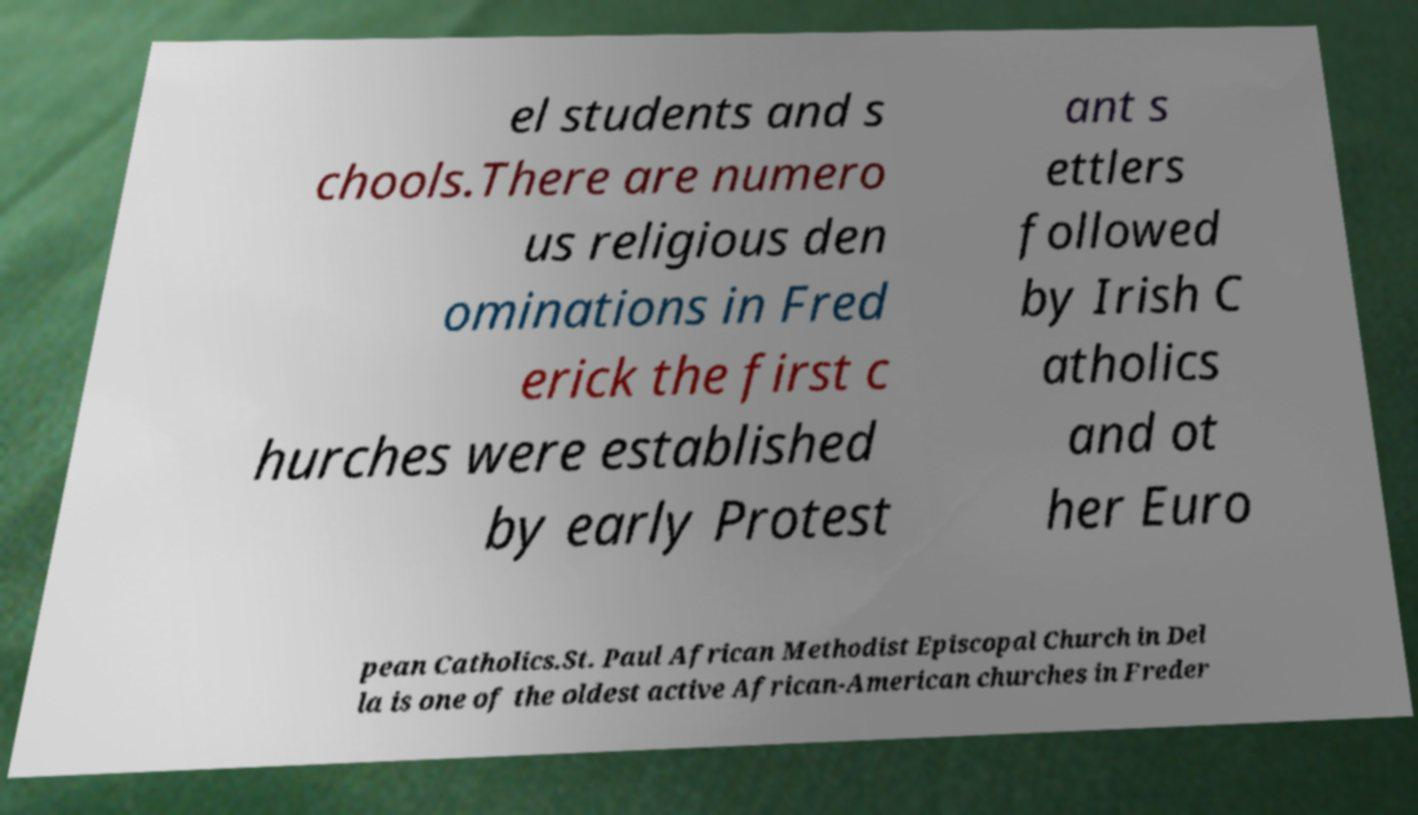I need the written content from this picture converted into text. Can you do that? el students and s chools.There are numero us religious den ominations in Fred erick the first c hurches were established by early Protest ant s ettlers followed by Irish C atholics and ot her Euro pean Catholics.St. Paul African Methodist Episcopal Church in Del la is one of the oldest active African-American churches in Freder 